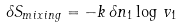<formula> <loc_0><loc_0><loc_500><loc_500>\delta S _ { m i x i n g } = - k \, \delta n _ { 1 } \log \, v _ { 1 }</formula> 